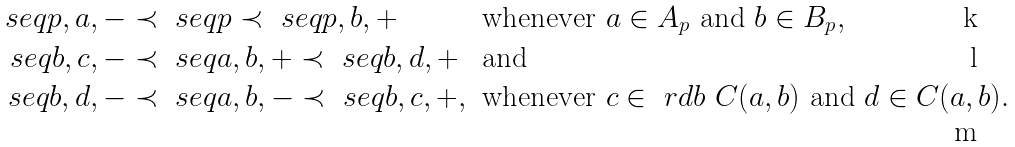<formula> <loc_0><loc_0><loc_500><loc_500>\ s e q { p , a , - } & \prec \ s e q { p } \prec \ s e q { p , b , + } & & \text {whenever } a \in A _ { p } \text { and } b \in B _ { p } , \\ \ s e q { b , c , - } & \prec \ s e q { a , b , + } \prec \ s e q { b , d , + } & & \text {and} \\ \ s e q { b , d , - } & \prec \ s e q { a , b , - } \prec \ s e q { b , c , + } , & & \text {whenever } c \in \ r d { b } \ C ( a , b ) \text { and } d \in C ( a , b ) .</formula> 